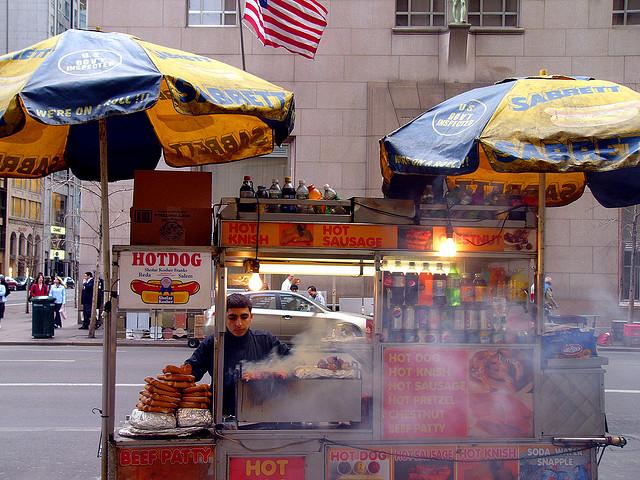Would this vendor likely have ketchup at his stand?
Keep it brief. Yes. Is this a hot dog stand?
Answer briefly. Yes. Does this vendor sell soda?
Give a very brief answer. Yes. 